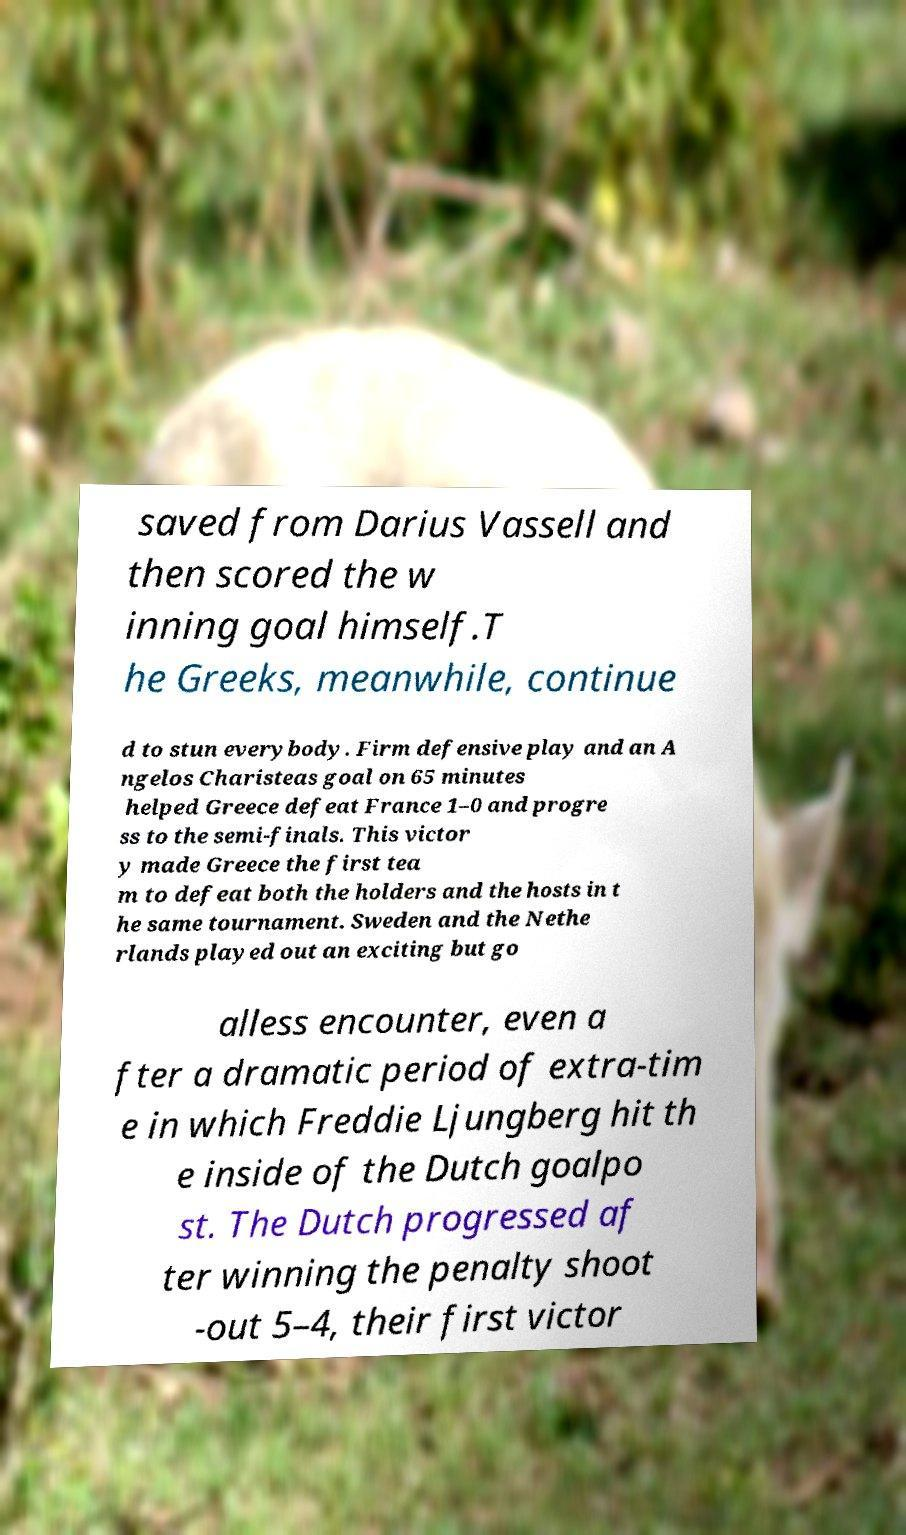For documentation purposes, I need the text within this image transcribed. Could you provide that? saved from Darius Vassell and then scored the w inning goal himself.T he Greeks, meanwhile, continue d to stun everybody. Firm defensive play and an A ngelos Charisteas goal on 65 minutes helped Greece defeat France 1–0 and progre ss to the semi-finals. This victor y made Greece the first tea m to defeat both the holders and the hosts in t he same tournament. Sweden and the Nethe rlands played out an exciting but go alless encounter, even a fter a dramatic period of extra-tim e in which Freddie Ljungberg hit th e inside of the Dutch goalpo st. The Dutch progressed af ter winning the penalty shoot -out 5–4, their first victor 